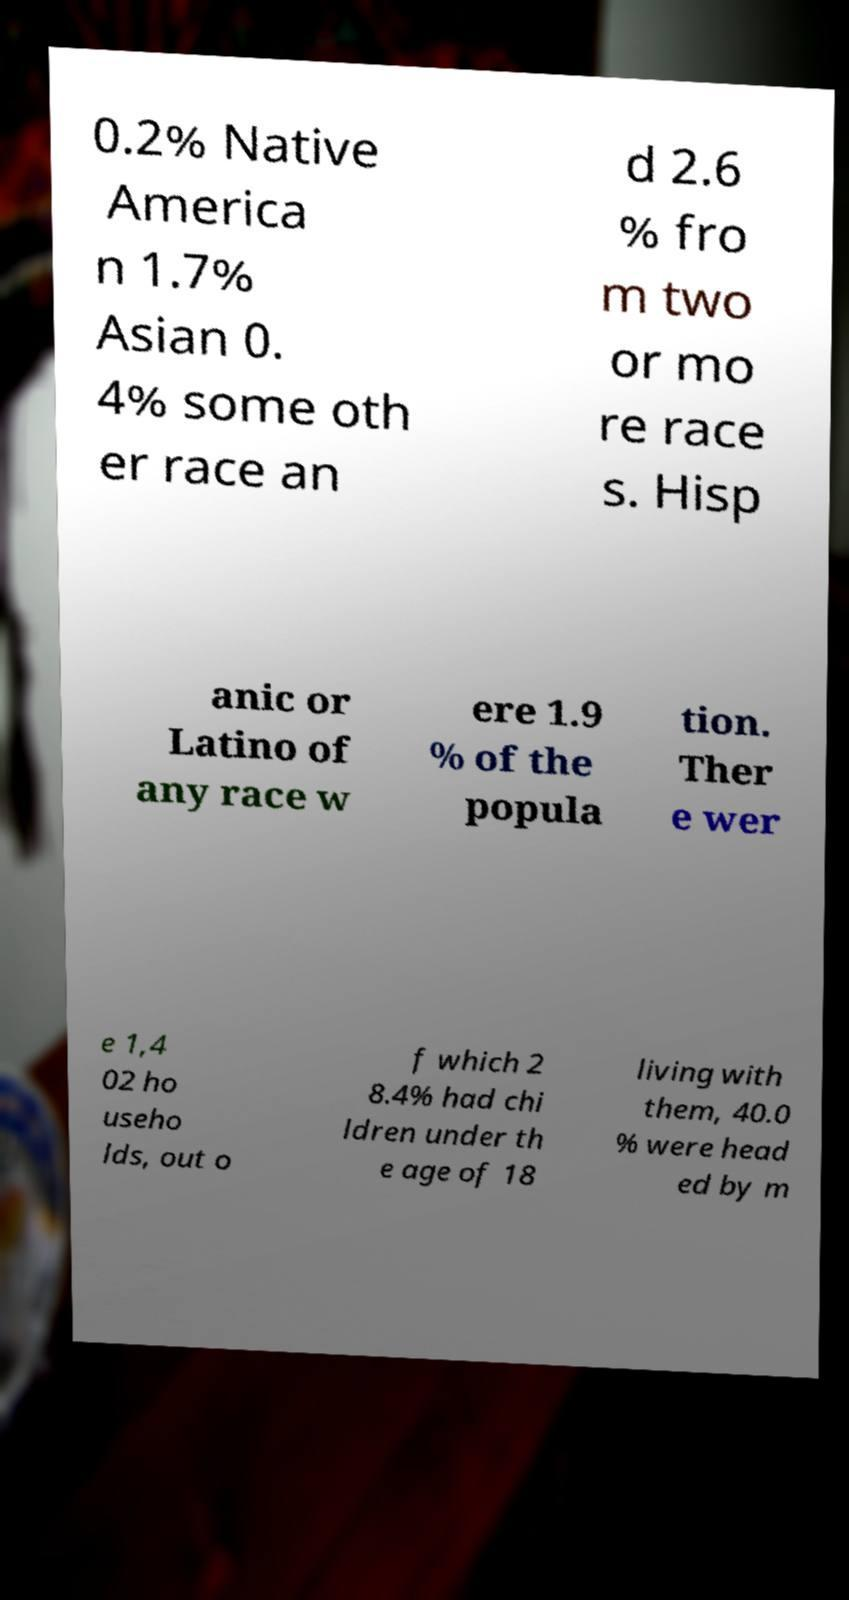There's text embedded in this image that I need extracted. Can you transcribe it verbatim? 0.2% Native America n 1.7% Asian 0. 4% some oth er race an d 2.6 % fro m two or mo re race s. Hisp anic or Latino of any race w ere 1.9 % of the popula tion. Ther e wer e 1,4 02 ho useho lds, out o f which 2 8.4% had chi ldren under th e age of 18 living with them, 40.0 % were head ed by m 